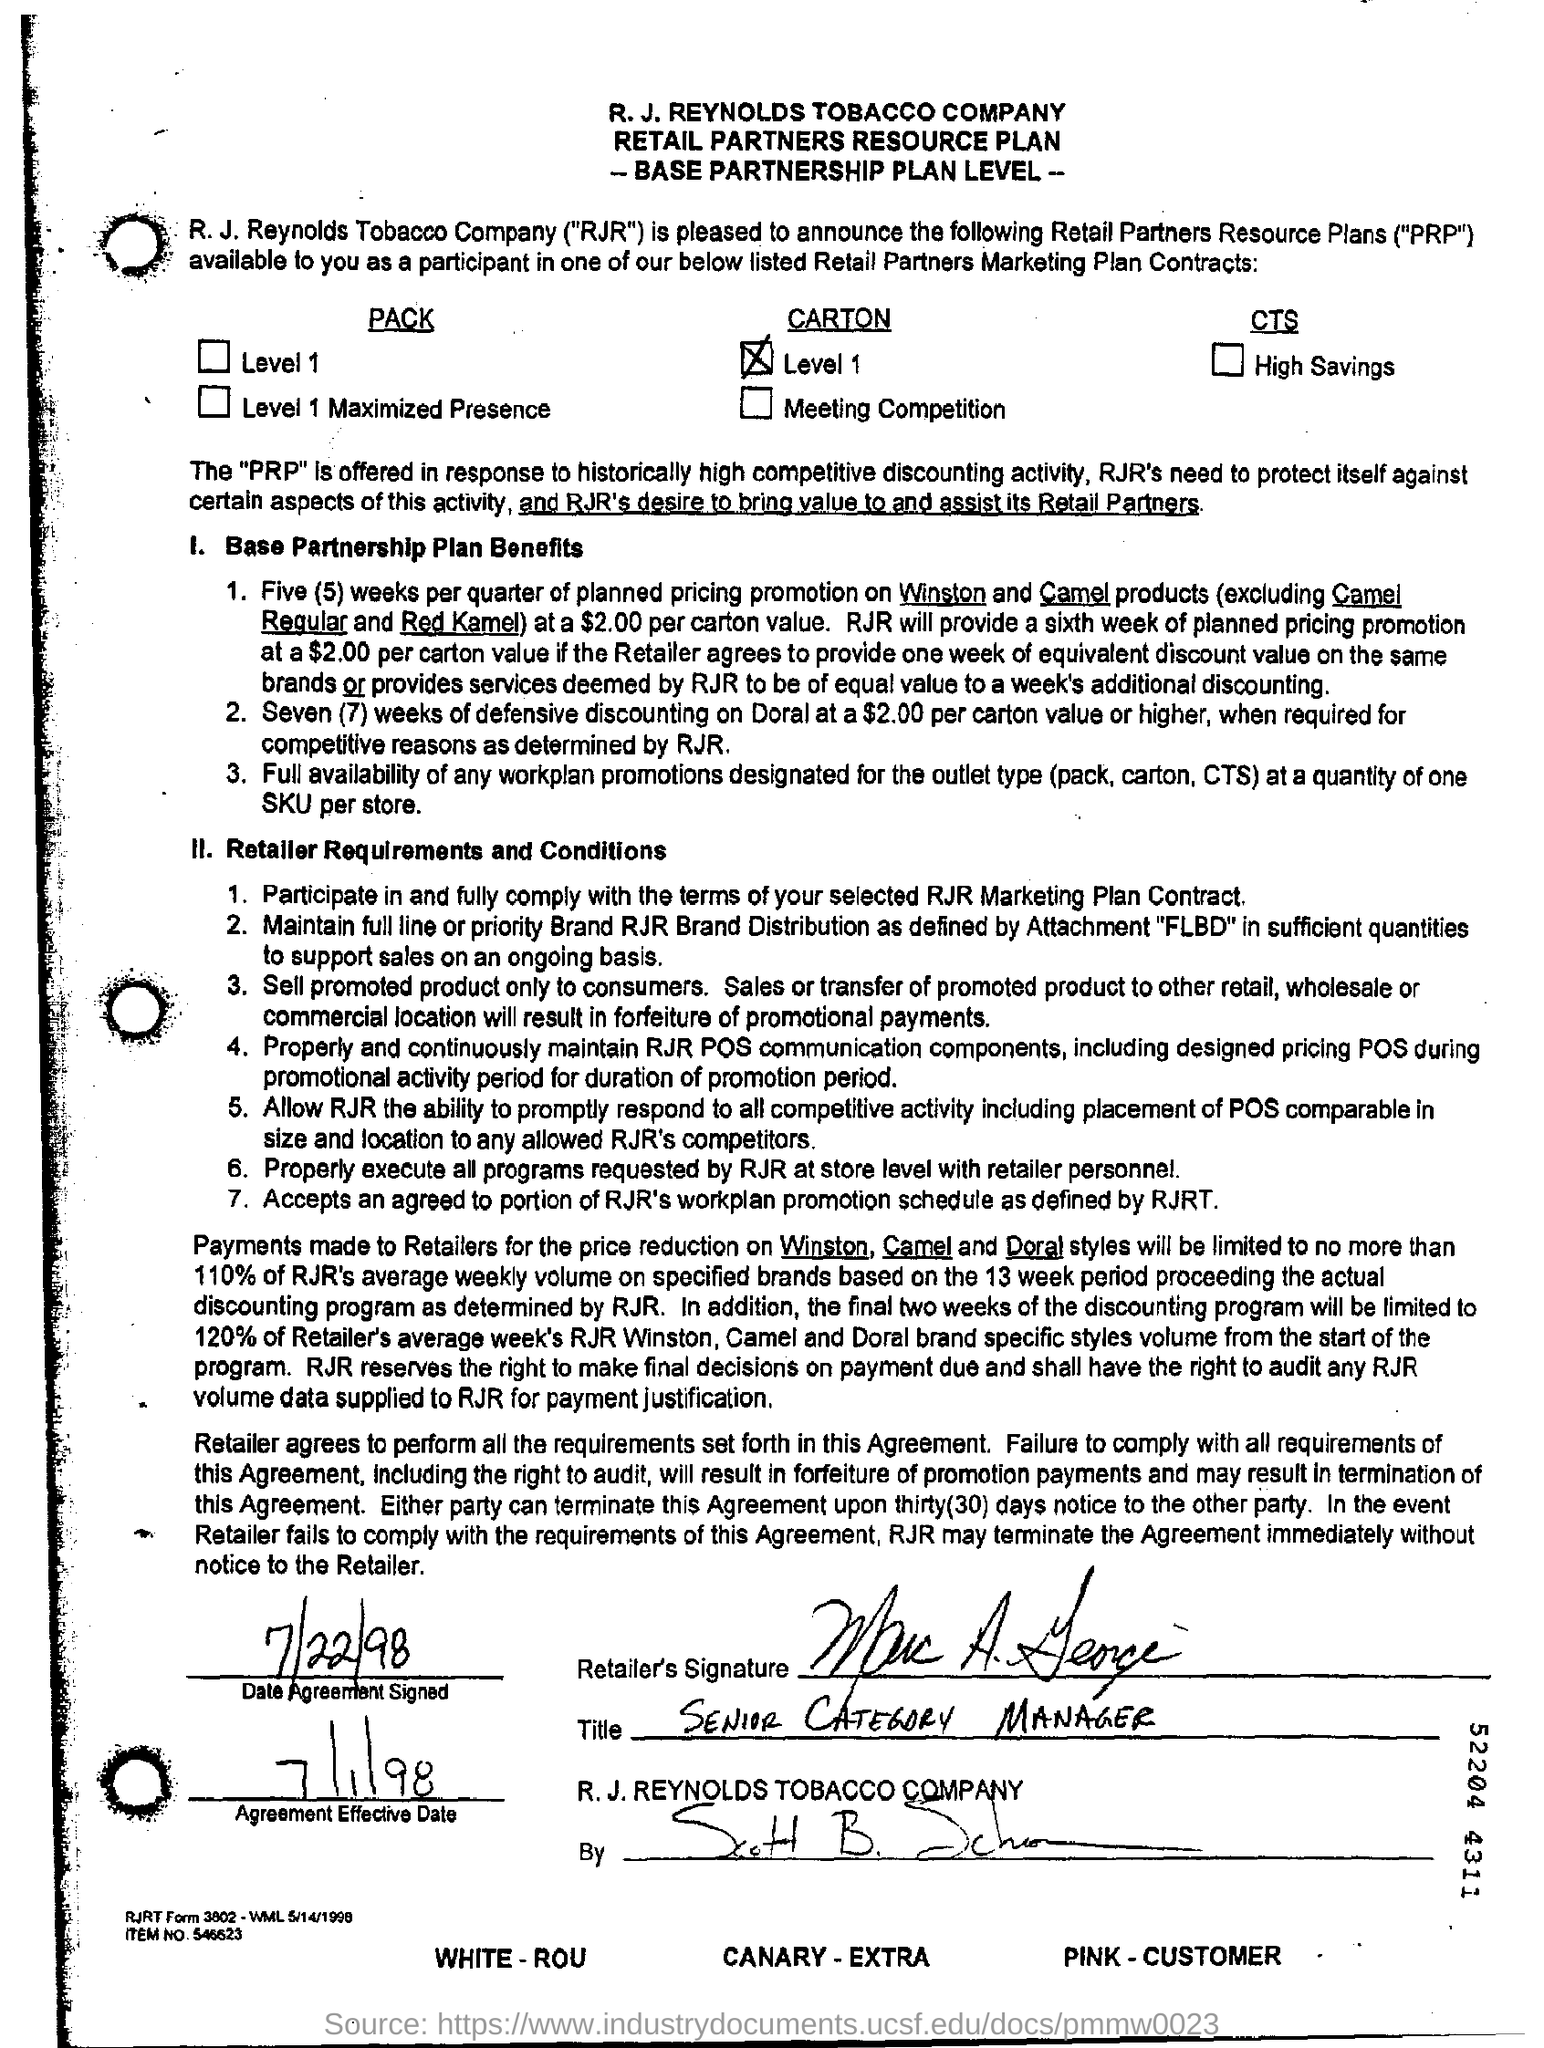Identify some key points in this picture. I am a Senior Category Manager at a retailer, and my title is [insert title here]. The agreement was signed on July 22, 1998. The agreement became effective on July 1, 1998. The named company is the R. J. Reynolds Tobacco Company. 